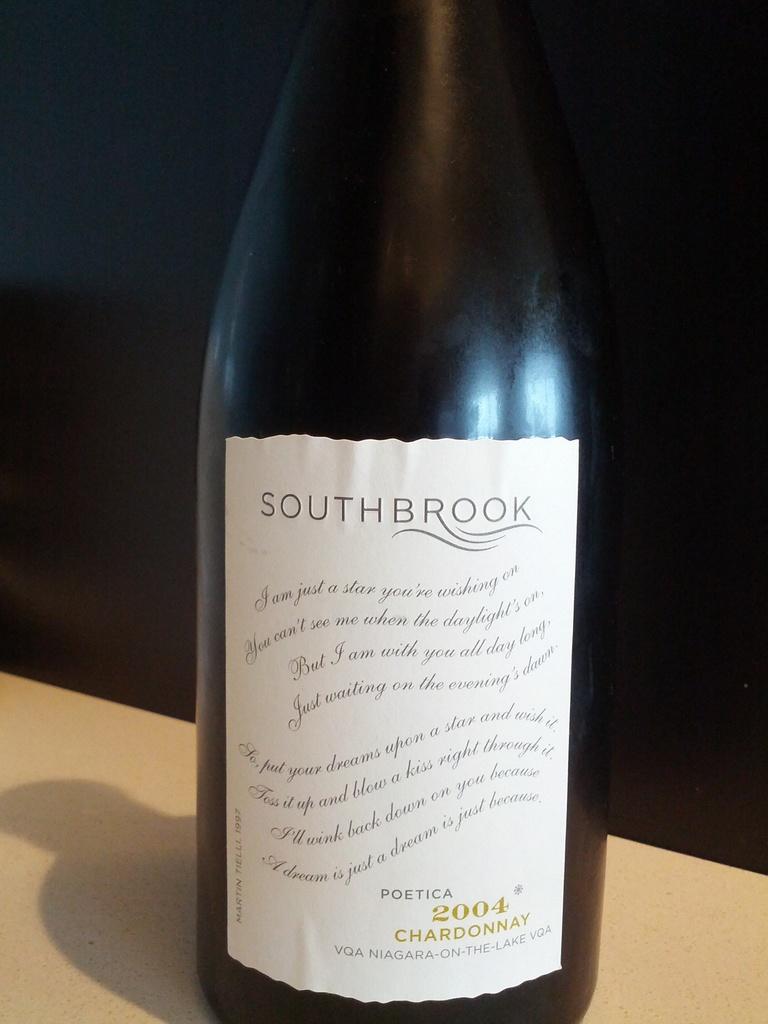What year is the bottle?
Make the answer very short. 2004. What type of wine is this?
Offer a terse response. Chardonnay. 